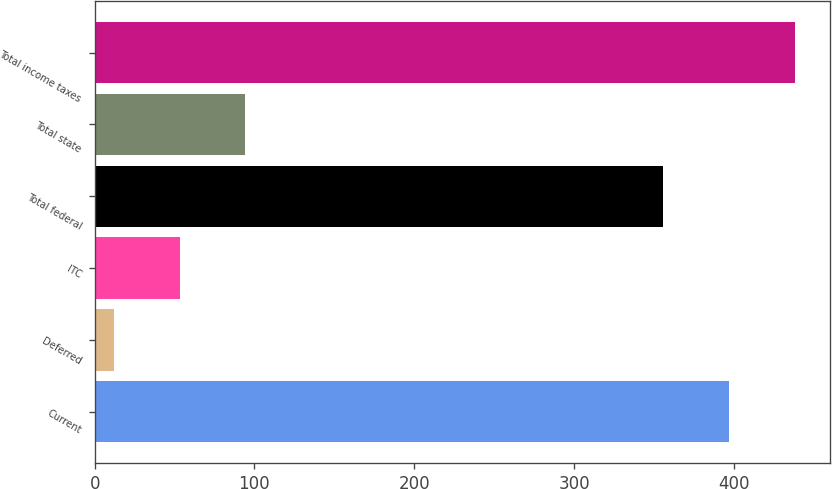Convert chart. <chart><loc_0><loc_0><loc_500><loc_500><bar_chart><fcel>Current<fcel>Deferred<fcel>ITC<fcel>Total federal<fcel>Total state<fcel>Total income taxes<nl><fcel>397.2<fcel>12<fcel>53.2<fcel>356<fcel>94.4<fcel>438.4<nl></chart> 